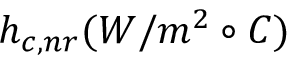Convert formula to latex. <formula><loc_0><loc_0><loc_500><loc_500>h _ { c , n r } ( W / m ^ { 2 } \circ C )</formula> 